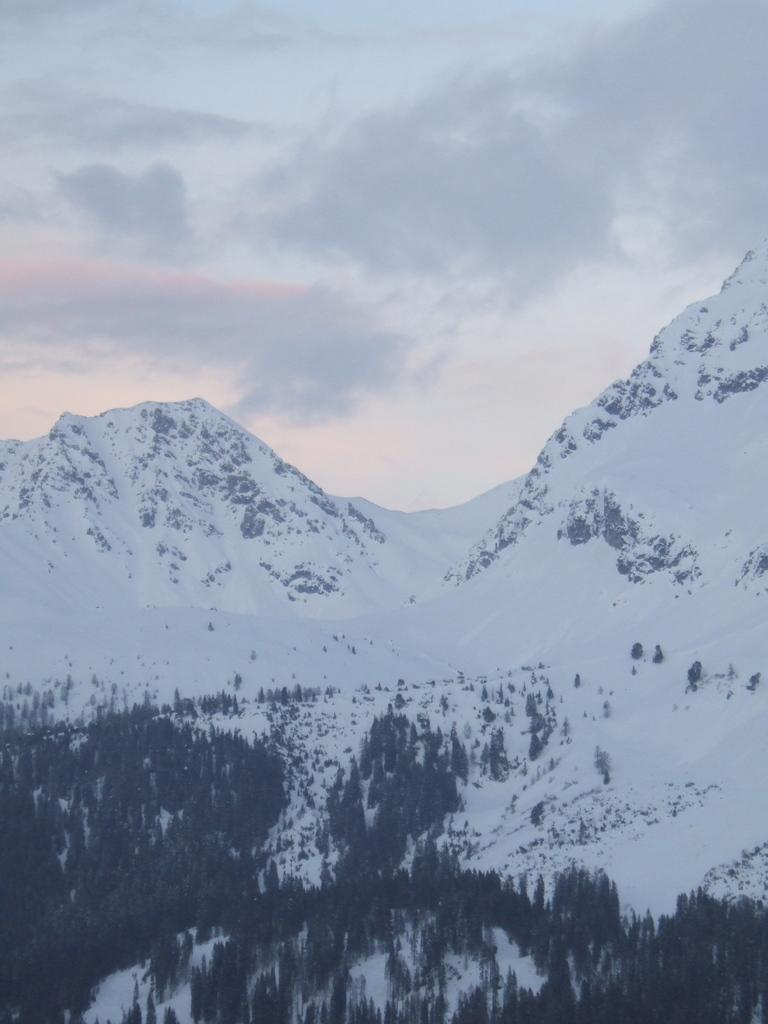What can be seen at the top of the image? The sky is visible in the image. What is present in the sky? Clouds are present in the sky. What type of natural features can be seen in the image? There are mountains and trees in the image. What type of sheet is covering the mountains in the image? There is no sheet present in the image; the mountains are visible without any covering. 